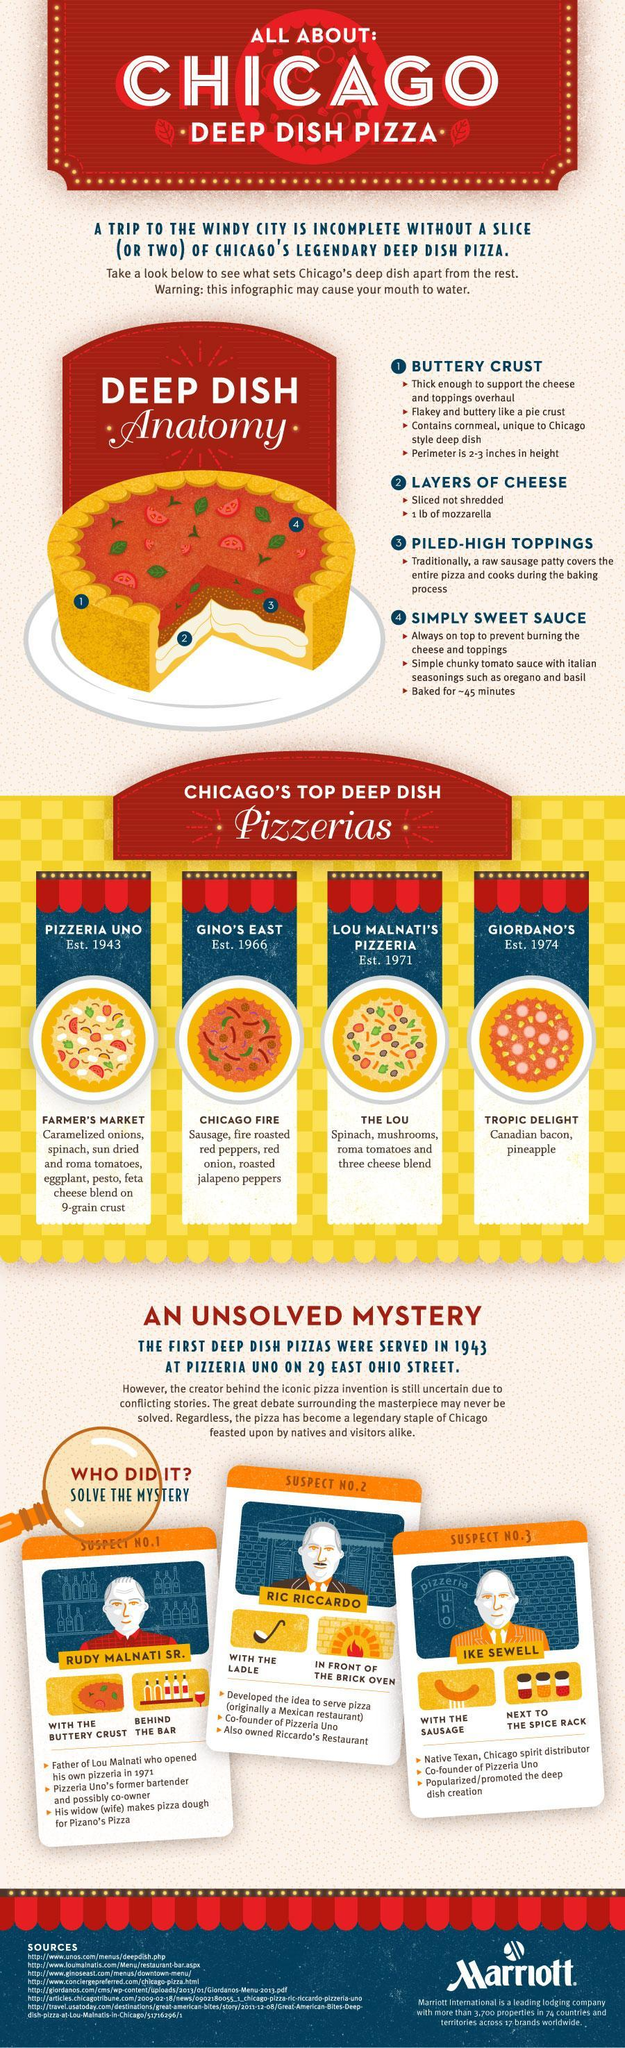What is the thickness of the pizza perimeter?
Answer the question with a short phrase. 2-3 inches Which is the oldest pizzeria listed in the infographic? Pizzeria Uno 